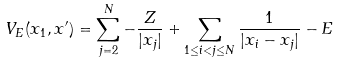<formula> <loc_0><loc_0><loc_500><loc_500>V _ { E } ( x _ { 1 } , x ^ { \prime } ) = \sum _ { j = 2 } ^ { N } - \frac { Z } { | x _ { j } | } + \sum _ { 1 \leq i < j \leq N } \frac { 1 } { | x _ { i } - x _ { j } | } - E</formula> 